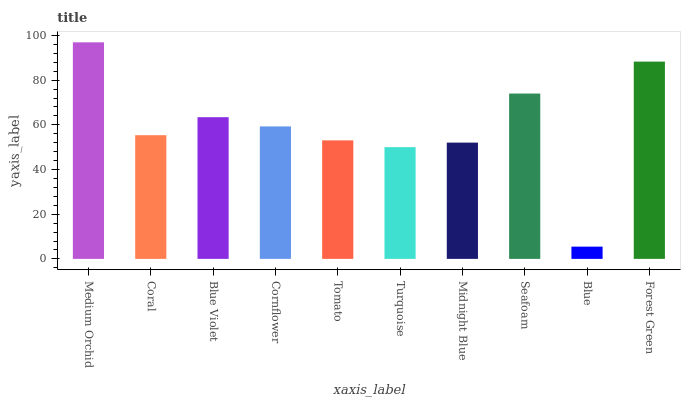Is Blue the minimum?
Answer yes or no. Yes. Is Medium Orchid the maximum?
Answer yes or no. Yes. Is Coral the minimum?
Answer yes or no. No. Is Coral the maximum?
Answer yes or no. No. Is Medium Orchid greater than Coral?
Answer yes or no. Yes. Is Coral less than Medium Orchid?
Answer yes or no. Yes. Is Coral greater than Medium Orchid?
Answer yes or no. No. Is Medium Orchid less than Coral?
Answer yes or no. No. Is Cornflower the high median?
Answer yes or no. Yes. Is Coral the low median?
Answer yes or no. Yes. Is Tomato the high median?
Answer yes or no. No. Is Seafoam the low median?
Answer yes or no. No. 